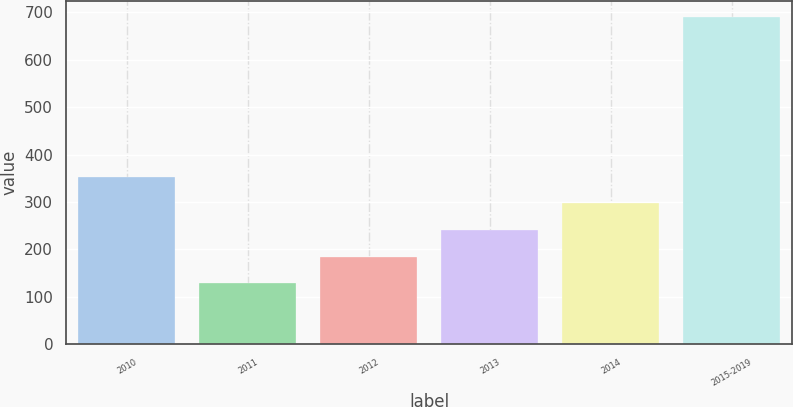Convert chart. <chart><loc_0><loc_0><loc_500><loc_500><bar_chart><fcel>2010<fcel>2011<fcel>2012<fcel>2013<fcel>2014<fcel>2015-2019<nl><fcel>353.14<fcel>128.7<fcel>184.81<fcel>240.92<fcel>297.03<fcel>689.8<nl></chart> 